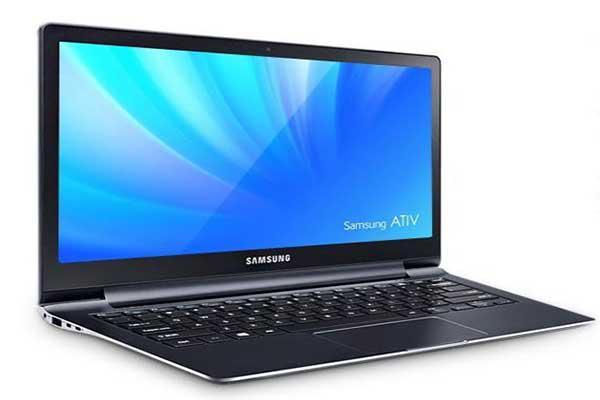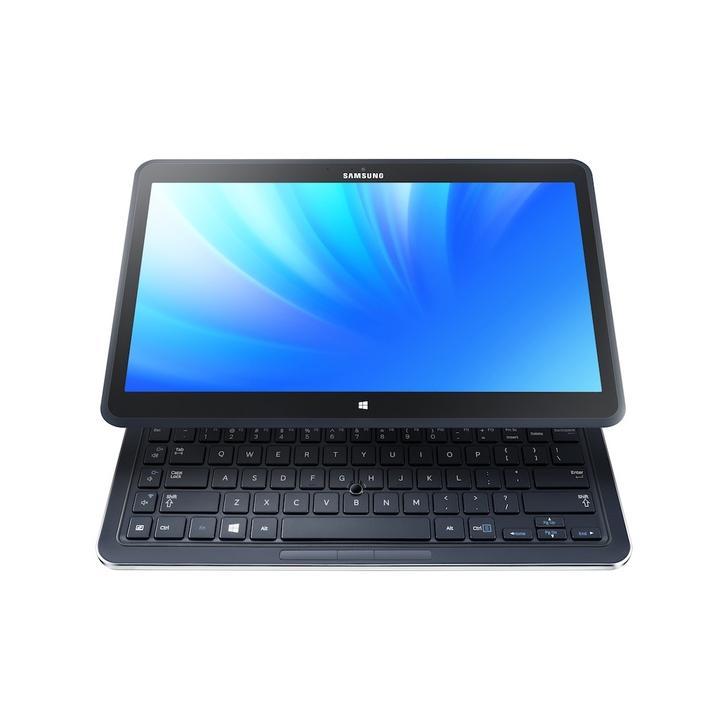The first image is the image on the left, the second image is the image on the right. Evaluate the accuracy of this statement regarding the images: "One photo contains multiple laptops.". Is it true? Answer yes or no. No. The first image is the image on the left, the second image is the image on the right. Assess this claim about the two images: "Each image contains exactly one laptop-type device.". Correct or not? Answer yes or no. Yes. 